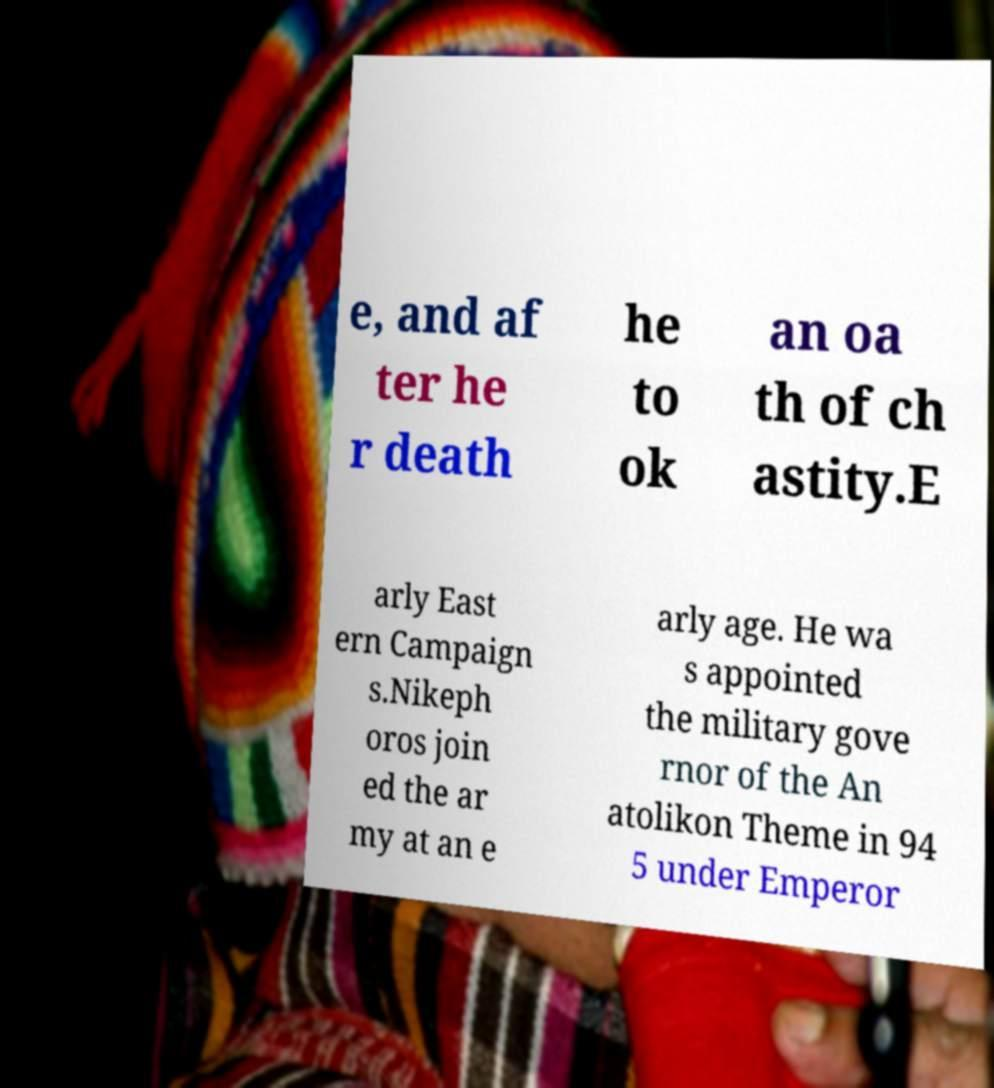For documentation purposes, I need the text within this image transcribed. Could you provide that? e, and af ter he r death he to ok an oa th of ch astity.E arly East ern Campaign s.Nikeph oros join ed the ar my at an e arly age. He wa s appointed the military gove rnor of the An atolikon Theme in 94 5 under Emperor 